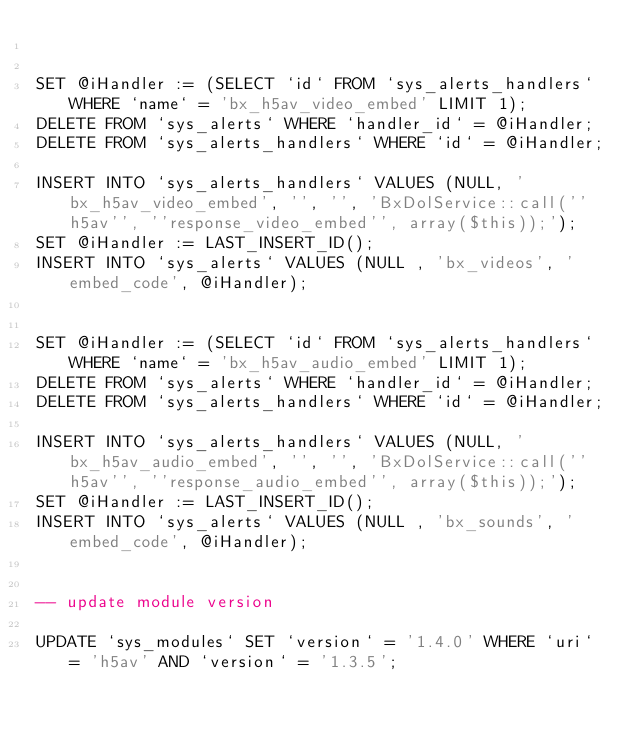<code> <loc_0><loc_0><loc_500><loc_500><_SQL_>

SET @iHandler := (SELECT `id` FROM `sys_alerts_handlers` WHERE `name` = 'bx_h5av_video_embed' LIMIT 1);
DELETE FROM `sys_alerts` WHERE `handler_id` = @iHandler;
DELETE FROM `sys_alerts_handlers` WHERE `id` = @iHandler;

INSERT INTO `sys_alerts_handlers` VALUES (NULL, 'bx_h5av_video_embed', '', '', 'BxDolService::call(''h5av'', ''response_video_embed'', array($this));');
SET @iHandler := LAST_INSERT_ID();
INSERT INTO `sys_alerts` VALUES (NULL , 'bx_videos', 'embed_code', @iHandler);


SET @iHandler := (SELECT `id` FROM `sys_alerts_handlers` WHERE `name` = 'bx_h5av_audio_embed' LIMIT 1);
DELETE FROM `sys_alerts` WHERE `handler_id` = @iHandler;
DELETE FROM `sys_alerts_handlers` WHERE `id` = @iHandler;

INSERT INTO `sys_alerts_handlers` VALUES (NULL, 'bx_h5av_audio_embed', '', '', 'BxDolService::call(''h5av'', ''response_audio_embed'', array($this));');
SET @iHandler := LAST_INSERT_ID();
INSERT INTO `sys_alerts` VALUES (NULL , 'bx_sounds', 'embed_code', @iHandler);


-- update module version

UPDATE `sys_modules` SET `version` = '1.4.0' WHERE `uri` = 'h5av' AND `version` = '1.3.5';

</code> 